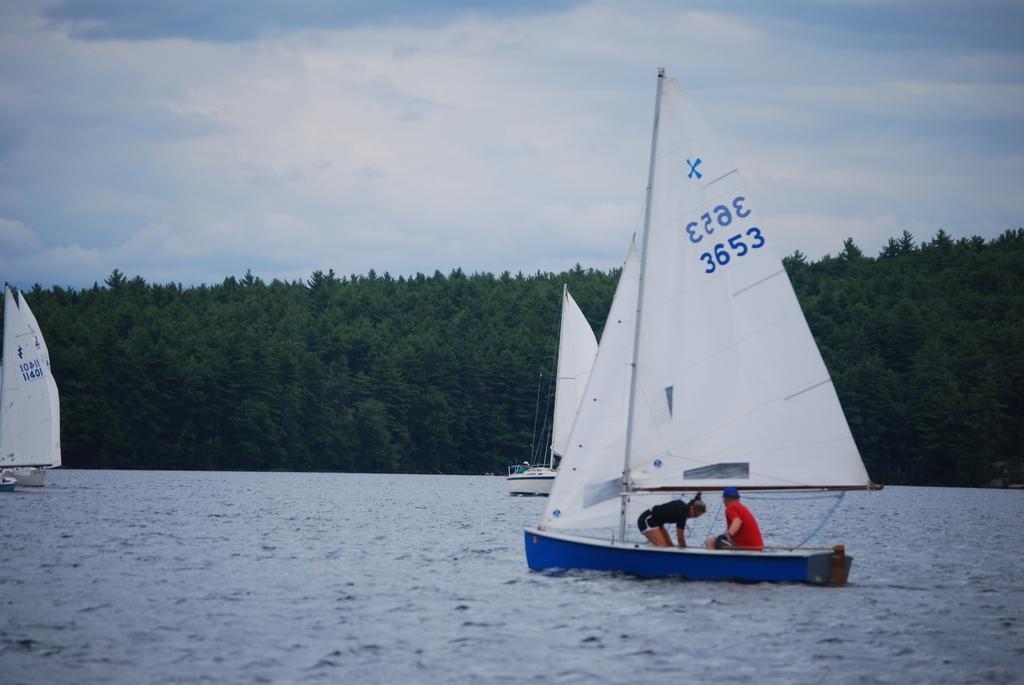Can you describe this image briefly? In the foreground of the picture there is a water body, in the water there are boats. In the boat there are people. In the background there are trees. Sky is partially cloudy. 